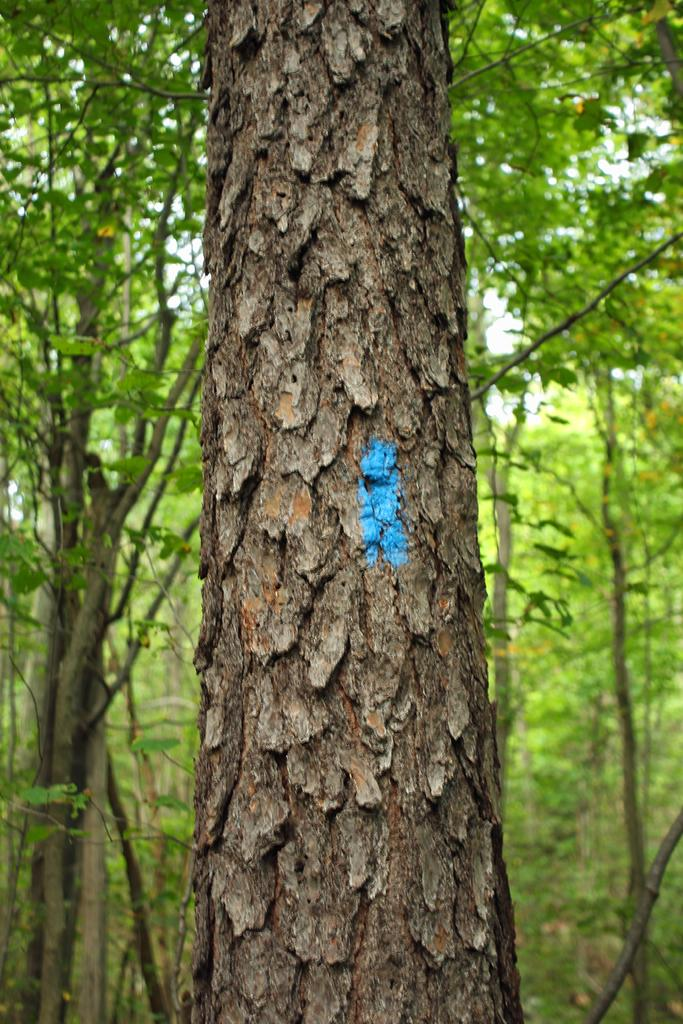What is the main subject of the image? The main subject of the image is a tree trunk. Can you describe the background of the image? In the background, there are trees with branches and leaves. What type of dress is hanging on the tree trunk in the image? There is no dress present in the image; it features a tree trunk and trees in the background. 